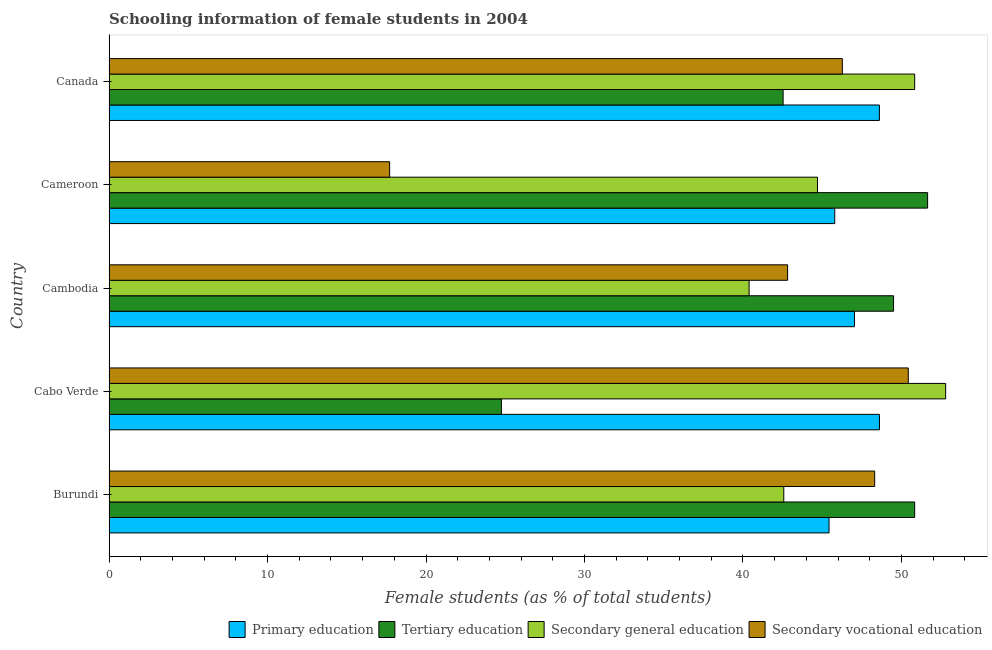How many different coloured bars are there?
Your answer should be compact. 4. How many groups of bars are there?
Provide a short and direct response. 5. Are the number of bars on each tick of the Y-axis equal?
Your answer should be compact. Yes. How many bars are there on the 5th tick from the top?
Your response must be concise. 4. What is the label of the 2nd group of bars from the top?
Make the answer very short. Cameroon. What is the percentage of female students in primary education in Burundi?
Keep it short and to the point. 45.43. Across all countries, what is the maximum percentage of female students in tertiary education?
Your answer should be very brief. 51.65. Across all countries, what is the minimum percentage of female students in secondary vocational education?
Make the answer very short. 17.7. In which country was the percentage of female students in secondary vocational education maximum?
Provide a succinct answer. Cabo Verde. In which country was the percentage of female students in tertiary education minimum?
Offer a terse response. Cabo Verde. What is the total percentage of female students in secondary vocational education in the graph?
Keep it short and to the point. 205.53. What is the difference between the percentage of female students in secondary vocational education in Burundi and that in Cambodia?
Keep it short and to the point. 5.5. What is the difference between the percentage of female students in tertiary education in Burundi and the percentage of female students in secondary education in Canada?
Keep it short and to the point. 0. What is the average percentage of female students in secondary education per country?
Offer a very short reply. 46.26. What is the difference between the percentage of female students in secondary vocational education and percentage of female students in tertiary education in Burundi?
Offer a terse response. -2.52. What is the ratio of the percentage of female students in secondary education in Burundi to that in Canada?
Offer a terse response. 0.84. Is the percentage of female students in tertiary education in Cabo Verde less than that in Cameroon?
Your answer should be very brief. Yes. Is the difference between the percentage of female students in tertiary education in Burundi and Cameroon greater than the difference between the percentage of female students in secondary vocational education in Burundi and Cameroon?
Your answer should be compact. No. What is the difference between the highest and the second highest percentage of female students in secondary education?
Your answer should be very brief. 1.96. What is the difference between the highest and the lowest percentage of female students in secondary vocational education?
Offer a terse response. 32.73. In how many countries, is the percentage of female students in primary education greater than the average percentage of female students in primary education taken over all countries?
Your response must be concise. 2. What does the 3rd bar from the top in Cameroon represents?
Offer a terse response. Tertiary education. What does the 1st bar from the bottom in Canada represents?
Ensure brevity in your answer.  Primary education. How many countries are there in the graph?
Keep it short and to the point. 5. What is the difference between two consecutive major ticks on the X-axis?
Provide a succinct answer. 10. Does the graph contain any zero values?
Offer a very short reply. No. Does the graph contain grids?
Ensure brevity in your answer.  No. Where does the legend appear in the graph?
Your response must be concise. Bottom right. How are the legend labels stacked?
Give a very brief answer. Horizontal. What is the title of the graph?
Your answer should be very brief. Schooling information of female students in 2004. Does "Permanent crop land" appear as one of the legend labels in the graph?
Provide a succinct answer. No. What is the label or title of the X-axis?
Your answer should be very brief. Female students (as % of total students). What is the Female students (as % of total students) in Primary education in Burundi?
Keep it short and to the point. 45.43. What is the Female students (as % of total students) of Tertiary education in Burundi?
Make the answer very short. 50.83. What is the Female students (as % of total students) of Secondary general education in Burundi?
Ensure brevity in your answer.  42.57. What is the Female students (as % of total students) of Secondary vocational education in Burundi?
Offer a very short reply. 48.31. What is the Female students (as % of total students) in Primary education in Cabo Verde?
Keep it short and to the point. 48.61. What is the Female students (as % of total students) in Tertiary education in Cabo Verde?
Offer a very short reply. 24.76. What is the Female students (as % of total students) in Secondary general education in Cabo Verde?
Give a very brief answer. 52.79. What is the Female students (as % of total students) of Secondary vocational education in Cabo Verde?
Provide a succinct answer. 50.43. What is the Female students (as % of total students) in Primary education in Cambodia?
Your answer should be very brief. 47.03. What is the Female students (as % of total students) in Tertiary education in Cambodia?
Your answer should be very brief. 49.5. What is the Female students (as % of total students) in Secondary general education in Cambodia?
Your response must be concise. 40.39. What is the Female students (as % of total students) of Secondary vocational education in Cambodia?
Provide a succinct answer. 42.81. What is the Female students (as % of total students) of Primary education in Cameroon?
Give a very brief answer. 45.79. What is the Female students (as % of total students) in Tertiary education in Cameroon?
Make the answer very short. 51.65. What is the Female students (as % of total students) in Secondary general education in Cameroon?
Your answer should be very brief. 44.7. What is the Female students (as % of total students) of Secondary vocational education in Cameroon?
Offer a very short reply. 17.7. What is the Female students (as % of total students) of Primary education in Canada?
Provide a short and direct response. 48.61. What is the Female students (as % of total students) in Tertiary education in Canada?
Give a very brief answer. 42.53. What is the Female students (as % of total students) in Secondary general education in Canada?
Offer a very short reply. 50.83. What is the Female students (as % of total students) in Secondary vocational education in Canada?
Provide a short and direct response. 46.27. Across all countries, what is the maximum Female students (as % of total students) in Primary education?
Provide a succinct answer. 48.61. Across all countries, what is the maximum Female students (as % of total students) of Tertiary education?
Offer a very short reply. 51.65. Across all countries, what is the maximum Female students (as % of total students) in Secondary general education?
Keep it short and to the point. 52.79. Across all countries, what is the maximum Female students (as % of total students) in Secondary vocational education?
Give a very brief answer. 50.43. Across all countries, what is the minimum Female students (as % of total students) in Primary education?
Provide a succinct answer. 45.43. Across all countries, what is the minimum Female students (as % of total students) in Tertiary education?
Give a very brief answer. 24.76. Across all countries, what is the minimum Female students (as % of total students) of Secondary general education?
Make the answer very short. 40.39. Across all countries, what is the minimum Female students (as % of total students) in Secondary vocational education?
Offer a very short reply. 17.7. What is the total Female students (as % of total students) in Primary education in the graph?
Offer a terse response. 235.47. What is the total Female students (as % of total students) of Tertiary education in the graph?
Make the answer very short. 219.27. What is the total Female students (as % of total students) of Secondary general education in the graph?
Keep it short and to the point. 231.28. What is the total Female students (as % of total students) in Secondary vocational education in the graph?
Your answer should be compact. 205.53. What is the difference between the Female students (as % of total students) in Primary education in Burundi and that in Cabo Verde?
Your response must be concise. -3.18. What is the difference between the Female students (as % of total students) of Tertiary education in Burundi and that in Cabo Verde?
Your response must be concise. 26.08. What is the difference between the Female students (as % of total students) of Secondary general education in Burundi and that in Cabo Verde?
Your answer should be compact. -10.21. What is the difference between the Female students (as % of total students) in Secondary vocational education in Burundi and that in Cabo Verde?
Your response must be concise. -2.12. What is the difference between the Female students (as % of total students) in Primary education in Burundi and that in Cambodia?
Ensure brevity in your answer.  -1.6. What is the difference between the Female students (as % of total students) of Tertiary education in Burundi and that in Cambodia?
Ensure brevity in your answer.  1.33. What is the difference between the Female students (as % of total students) in Secondary general education in Burundi and that in Cambodia?
Your response must be concise. 2.19. What is the difference between the Female students (as % of total students) of Secondary vocational education in Burundi and that in Cambodia?
Keep it short and to the point. 5.49. What is the difference between the Female students (as % of total students) in Primary education in Burundi and that in Cameroon?
Your answer should be very brief. -0.36. What is the difference between the Female students (as % of total students) in Tertiary education in Burundi and that in Cameroon?
Provide a short and direct response. -0.82. What is the difference between the Female students (as % of total students) of Secondary general education in Burundi and that in Cameroon?
Ensure brevity in your answer.  -2.13. What is the difference between the Female students (as % of total students) of Secondary vocational education in Burundi and that in Cameroon?
Make the answer very short. 30.6. What is the difference between the Female students (as % of total students) of Primary education in Burundi and that in Canada?
Provide a short and direct response. -3.18. What is the difference between the Female students (as % of total students) in Tertiary education in Burundi and that in Canada?
Provide a short and direct response. 8.3. What is the difference between the Female students (as % of total students) in Secondary general education in Burundi and that in Canada?
Keep it short and to the point. -8.26. What is the difference between the Female students (as % of total students) of Secondary vocational education in Burundi and that in Canada?
Make the answer very short. 2.04. What is the difference between the Female students (as % of total students) of Primary education in Cabo Verde and that in Cambodia?
Your answer should be compact. 1.58. What is the difference between the Female students (as % of total students) in Tertiary education in Cabo Verde and that in Cambodia?
Your answer should be very brief. -24.74. What is the difference between the Female students (as % of total students) in Secondary general education in Cabo Verde and that in Cambodia?
Your answer should be very brief. 12.4. What is the difference between the Female students (as % of total students) in Secondary vocational education in Cabo Verde and that in Cambodia?
Give a very brief answer. 7.62. What is the difference between the Female students (as % of total students) in Primary education in Cabo Verde and that in Cameroon?
Give a very brief answer. 2.82. What is the difference between the Female students (as % of total students) in Tertiary education in Cabo Verde and that in Cameroon?
Give a very brief answer. -26.89. What is the difference between the Female students (as % of total students) of Secondary general education in Cabo Verde and that in Cameroon?
Offer a very short reply. 8.09. What is the difference between the Female students (as % of total students) of Secondary vocational education in Cabo Verde and that in Cameroon?
Make the answer very short. 32.73. What is the difference between the Female students (as % of total students) of Primary education in Cabo Verde and that in Canada?
Your response must be concise. 0. What is the difference between the Female students (as % of total students) of Tertiary education in Cabo Verde and that in Canada?
Offer a very short reply. -17.78. What is the difference between the Female students (as % of total students) in Secondary general education in Cabo Verde and that in Canada?
Ensure brevity in your answer.  1.96. What is the difference between the Female students (as % of total students) in Secondary vocational education in Cabo Verde and that in Canada?
Keep it short and to the point. 4.16. What is the difference between the Female students (as % of total students) of Primary education in Cambodia and that in Cameroon?
Your answer should be compact. 1.24. What is the difference between the Female students (as % of total students) in Tertiary education in Cambodia and that in Cameroon?
Ensure brevity in your answer.  -2.15. What is the difference between the Female students (as % of total students) of Secondary general education in Cambodia and that in Cameroon?
Provide a short and direct response. -4.31. What is the difference between the Female students (as % of total students) of Secondary vocational education in Cambodia and that in Cameroon?
Give a very brief answer. 25.11. What is the difference between the Female students (as % of total students) of Primary education in Cambodia and that in Canada?
Your response must be concise. -1.57. What is the difference between the Female students (as % of total students) in Tertiary education in Cambodia and that in Canada?
Keep it short and to the point. 6.97. What is the difference between the Female students (as % of total students) of Secondary general education in Cambodia and that in Canada?
Ensure brevity in your answer.  -10.45. What is the difference between the Female students (as % of total students) in Secondary vocational education in Cambodia and that in Canada?
Provide a short and direct response. -3.45. What is the difference between the Female students (as % of total students) of Primary education in Cameroon and that in Canada?
Offer a terse response. -2.82. What is the difference between the Female students (as % of total students) in Tertiary education in Cameroon and that in Canada?
Your response must be concise. 9.12. What is the difference between the Female students (as % of total students) of Secondary general education in Cameroon and that in Canada?
Your answer should be compact. -6.13. What is the difference between the Female students (as % of total students) in Secondary vocational education in Cameroon and that in Canada?
Offer a terse response. -28.56. What is the difference between the Female students (as % of total students) of Primary education in Burundi and the Female students (as % of total students) of Tertiary education in Cabo Verde?
Offer a very short reply. 20.67. What is the difference between the Female students (as % of total students) of Primary education in Burundi and the Female students (as % of total students) of Secondary general education in Cabo Verde?
Your answer should be compact. -7.36. What is the difference between the Female students (as % of total students) in Primary education in Burundi and the Female students (as % of total students) in Secondary vocational education in Cabo Verde?
Give a very brief answer. -5. What is the difference between the Female students (as % of total students) in Tertiary education in Burundi and the Female students (as % of total students) in Secondary general education in Cabo Verde?
Give a very brief answer. -1.96. What is the difference between the Female students (as % of total students) in Tertiary education in Burundi and the Female students (as % of total students) in Secondary vocational education in Cabo Verde?
Your answer should be compact. 0.4. What is the difference between the Female students (as % of total students) of Secondary general education in Burundi and the Female students (as % of total students) of Secondary vocational education in Cabo Verde?
Make the answer very short. -7.86. What is the difference between the Female students (as % of total students) of Primary education in Burundi and the Female students (as % of total students) of Tertiary education in Cambodia?
Give a very brief answer. -4.07. What is the difference between the Female students (as % of total students) of Primary education in Burundi and the Female students (as % of total students) of Secondary general education in Cambodia?
Offer a terse response. 5.04. What is the difference between the Female students (as % of total students) of Primary education in Burundi and the Female students (as % of total students) of Secondary vocational education in Cambodia?
Offer a terse response. 2.61. What is the difference between the Female students (as % of total students) of Tertiary education in Burundi and the Female students (as % of total students) of Secondary general education in Cambodia?
Make the answer very short. 10.45. What is the difference between the Female students (as % of total students) in Tertiary education in Burundi and the Female students (as % of total students) in Secondary vocational education in Cambodia?
Your answer should be very brief. 8.02. What is the difference between the Female students (as % of total students) in Secondary general education in Burundi and the Female students (as % of total students) in Secondary vocational education in Cambodia?
Your response must be concise. -0.24. What is the difference between the Female students (as % of total students) in Primary education in Burundi and the Female students (as % of total students) in Tertiary education in Cameroon?
Provide a succinct answer. -6.22. What is the difference between the Female students (as % of total students) of Primary education in Burundi and the Female students (as % of total students) of Secondary general education in Cameroon?
Ensure brevity in your answer.  0.73. What is the difference between the Female students (as % of total students) of Primary education in Burundi and the Female students (as % of total students) of Secondary vocational education in Cameroon?
Provide a short and direct response. 27.73. What is the difference between the Female students (as % of total students) of Tertiary education in Burundi and the Female students (as % of total students) of Secondary general education in Cameroon?
Your answer should be compact. 6.13. What is the difference between the Female students (as % of total students) in Tertiary education in Burundi and the Female students (as % of total students) in Secondary vocational education in Cameroon?
Ensure brevity in your answer.  33.13. What is the difference between the Female students (as % of total students) of Secondary general education in Burundi and the Female students (as % of total students) of Secondary vocational education in Cameroon?
Keep it short and to the point. 24.87. What is the difference between the Female students (as % of total students) in Primary education in Burundi and the Female students (as % of total students) in Tertiary education in Canada?
Give a very brief answer. 2.9. What is the difference between the Female students (as % of total students) of Primary education in Burundi and the Female students (as % of total students) of Secondary general education in Canada?
Offer a very short reply. -5.4. What is the difference between the Female students (as % of total students) of Primary education in Burundi and the Female students (as % of total students) of Secondary vocational education in Canada?
Make the answer very short. -0.84. What is the difference between the Female students (as % of total students) in Tertiary education in Burundi and the Female students (as % of total students) in Secondary general education in Canada?
Offer a terse response. 0. What is the difference between the Female students (as % of total students) of Tertiary education in Burundi and the Female students (as % of total students) of Secondary vocational education in Canada?
Ensure brevity in your answer.  4.56. What is the difference between the Female students (as % of total students) of Secondary general education in Burundi and the Female students (as % of total students) of Secondary vocational education in Canada?
Your response must be concise. -3.69. What is the difference between the Female students (as % of total students) in Primary education in Cabo Verde and the Female students (as % of total students) in Tertiary education in Cambodia?
Keep it short and to the point. -0.89. What is the difference between the Female students (as % of total students) of Primary education in Cabo Verde and the Female students (as % of total students) of Secondary general education in Cambodia?
Your response must be concise. 8.22. What is the difference between the Female students (as % of total students) of Primary education in Cabo Verde and the Female students (as % of total students) of Secondary vocational education in Cambodia?
Give a very brief answer. 5.79. What is the difference between the Female students (as % of total students) of Tertiary education in Cabo Verde and the Female students (as % of total students) of Secondary general education in Cambodia?
Offer a very short reply. -15.63. What is the difference between the Female students (as % of total students) in Tertiary education in Cabo Verde and the Female students (as % of total students) in Secondary vocational education in Cambodia?
Your answer should be compact. -18.06. What is the difference between the Female students (as % of total students) of Secondary general education in Cabo Verde and the Female students (as % of total students) of Secondary vocational education in Cambodia?
Provide a short and direct response. 9.97. What is the difference between the Female students (as % of total students) in Primary education in Cabo Verde and the Female students (as % of total students) in Tertiary education in Cameroon?
Offer a terse response. -3.04. What is the difference between the Female students (as % of total students) of Primary education in Cabo Verde and the Female students (as % of total students) of Secondary general education in Cameroon?
Keep it short and to the point. 3.91. What is the difference between the Female students (as % of total students) of Primary education in Cabo Verde and the Female students (as % of total students) of Secondary vocational education in Cameroon?
Make the answer very short. 30.91. What is the difference between the Female students (as % of total students) in Tertiary education in Cabo Verde and the Female students (as % of total students) in Secondary general education in Cameroon?
Your response must be concise. -19.94. What is the difference between the Female students (as % of total students) in Tertiary education in Cabo Verde and the Female students (as % of total students) in Secondary vocational education in Cameroon?
Offer a terse response. 7.05. What is the difference between the Female students (as % of total students) of Secondary general education in Cabo Verde and the Female students (as % of total students) of Secondary vocational education in Cameroon?
Provide a short and direct response. 35.08. What is the difference between the Female students (as % of total students) of Primary education in Cabo Verde and the Female students (as % of total students) of Tertiary education in Canada?
Provide a short and direct response. 6.08. What is the difference between the Female students (as % of total students) in Primary education in Cabo Verde and the Female students (as % of total students) in Secondary general education in Canada?
Provide a short and direct response. -2.22. What is the difference between the Female students (as % of total students) of Primary education in Cabo Verde and the Female students (as % of total students) of Secondary vocational education in Canada?
Keep it short and to the point. 2.34. What is the difference between the Female students (as % of total students) of Tertiary education in Cabo Verde and the Female students (as % of total students) of Secondary general education in Canada?
Your answer should be very brief. -26.08. What is the difference between the Female students (as % of total students) in Tertiary education in Cabo Verde and the Female students (as % of total students) in Secondary vocational education in Canada?
Offer a very short reply. -21.51. What is the difference between the Female students (as % of total students) of Secondary general education in Cabo Verde and the Female students (as % of total students) of Secondary vocational education in Canada?
Your response must be concise. 6.52. What is the difference between the Female students (as % of total students) in Primary education in Cambodia and the Female students (as % of total students) in Tertiary education in Cameroon?
Offer a terse response. -4.62. What is the difference between the Female students (as % of total students) of Primary education in Cambodia and the Female students (as % of total students) of Secondary general education in Cameroon?
Give a very brief answer. 2.33. What is the difference between the Female students (as % of total students) in Primary education in Cambodia and the Female students (as % of total students) in Secondary vocational education in Cameroon?
Provide a succinct answer. 29.33. What is the difference between the Female students (as % of total students) in Tertiary education in Cambodia and the Female students (as % of total students) in Secondary general education in Cameroon?
Provide a short and direct response. 4.8. What is the difference between the Female students (as % of total students) of Tertiary education in Cambodia and the Female students (as % of total students) of Secondary vocational education in Cameroon?
Offer a very short reply. 31.8. What is the difference between the Female students (as % of total students) in Secondary general education in Cambodia and the Female students (as % of total students) in Secondary vocational education in Cameroon?
Give a very brief answer. 22.68. What is the difference between the Female students (as % of total students) of Primary education in Cambodia and the Female students (as % of total students) of Tertiary education in Canada?
Your response must be concise. 4.5. What is the difference between the Female students (as % of total students) of Primary education in Cambodia and the Female students (as % of total students) of Secondary general education in Canada?
Offer a very short reply. -3.8. What is the difference between the Female students (as % of total students) of Primary education in Cambodia and the Female students (as % of total students) of Secondary vocational education in Canada?
Keep it short and to the point. 0.76. What is the difference between the Female students (as % of total students) in Tertiary education in Cambodia and the Female students (as % of total students) in Secondary general education in Canada?
Provide a succinct answer. -1.33. What is the difference between the Female students (as % of total students) of Tertiary education in Cambodia and the Female students (as % of total students) of Secondary vocational education in Canada?
Keep it short and to the point. 3.23. What is the difference between the Female students (as % of total students) in Secondary general education in Cambodia and the Female students (as % of total students) in Secondary vocational education in Canada?
Offer a very short reply. -5.88. What is the difference between the Female students (as % of total students) in Primary education in Cameroon and the Female students (as % of total students) in Tertiary education in Canada?
Make the answer very short. 3.26. What is the difference between the Female students (as % of total students) in Primary education in Cameroon and the Female students (as % of total students) in Secondary general education in Canada?
Keep it short and to the point. -5.04. What is the difference between the Female students (as % of total students) in Primary education in Cameroon and the Female students (as % of total students) in Secondary vocational education in Canada?
Your answer should be compact. -0.48. What is the difference between the Female students (as % of total students) in Tertiary education in Cameroon and the Female students (as % of total students) in Secondary general education in Canada?
Your response must be concise. 0.82. What is the difference between the Female students (as % of total students) in Tertiary education in Cameroon and the Female students (as % of total students) in Secondary vocational education in Canada?
Give a very brief answer. 5.38. What is the difference between the Female students (as % of total students) of Secondary general education in Cameroon and the Female students (as % of total students) of Secondary vocational education in Canada?
Provide a short and direct response. -1.57. What is the average Female students (as % of total students) in Primary education per country?
Your response must be concise. 47.09. What is the average Female students (as % of total students) of Tertiary education per country?
Your answer should be compact. 43.85. What is the average Female students (as % of total students) of Secondary general education per country?
Ensure brevity in your answer.  46.26. What is the average Female students (as % of total students) in Secondary vocational education per country?
Your answer should be compact. 41.11. What is the difference between the Female students (as % of total students) in Primary education and Female students (as % of total students) in Tertiary education in Burundi?
Make the answer very short. -5.4. What is the difference between the Female students (as % of total students) in Primary education and Female students (as % of total students) in Secondary general education in Burundi?
Offer a very short reply. 2.85. What is the difference between the Female students (as % of total students) of Primary education and Female students (as % of total students) of Secondary vocational education in Burundi?
Give a very brief answer. -2.88. What is the difference between the Female students (as % of total students) of Tertiary education and Female students (as % of total students) of Secondary general education in Burundi?
Keep it short and to the point. 8.26. What is the difference between the Female students (as % of total students) of Tertiary education and Female students (as % of total students) of Secondary vocational education in Burundi?
Your response must be concise. 2.52. What is the difference between the Female students (as % of total students) in Secondary general education and Female students (as % of total students) in Secondary vocational education in Burundi?
Make the answer very short. -5.73. What is the difference between the Female students (as % of total students) of Primary education and Female students (as % of total students) of Tertiary education in Cabo Verde?
Make the answer very short. 23.85. What is the difference between the Female students (as % of total students) in Primary education and Female students (as % of total students) in Secondary general education in Cabo Verde?
Your answer should be very brief. -4.18. What is the difference between the Female students (as % of total students) of Primary education and Female students (as % of total students) of Secondary vocational education in Cabo Verde?
Provide a succinct answer. -1.82. What is the difference between the Female students (as % of total students) in Tertiary education and Female students (as % of total students) in Secondary general education in Cabo Verde?
Give a very brief answer. -28.03. What is the difference between the Female students (as % of total students) in Tertiary education and Female students (as % of total students) in Secondary vocational education in Cabo Verde?
Offer a terse response. -25.67. What is the difference between the Female students (as % of total students) in Secondary general education and Female students (as % of total students) in Secondary vocational education in Cabo Verde?
Your answer should be very brief. 2.36. What is the difference between the Female students (as % of total students) of Primary education and Female students (as % of total students) of Tertiary education in Cambodia?
Give a very brief answer. -2.47. What is the difference between the Female students (as % of total students) of Primary education and Female students (as % of total students) of Secondary general education in Cambodia?
Offer a very short reply. 6.65. What is the difference between the Female students (as % of total students) of Primary education and Female students (as % of total students) of Secondary vocational education in Cambodia?
Provide a short and direct response. 4.22. What is the difference between the Female students (as % of total students) of Tertiary education and Female students (as % of total students) of Secondary general education in Cambodia?
Provide a short and direct response. 9.11. What is the difference between the Female students (as % of total students) of Tertiary education and Female students (as % of total students) of Secondary vocational education in Cambodia?
Your answer should be compact. 6.69. What is the difference between the Female students (as % of total students) in Secondary general education and Female students (as % of total students) in Secondary vocational education in Cambodia?
Offer a terse response. -2.43. What is the difference between the Female students (as % of total students) in Primary education and Female students (as % of total students) in Tertiary education in Cameroon?
Offer a very short reply. -5.86. What is the difference between the Female students (as % of total students) in Primary education and Female students (as % of total students) in Secondary general education in Cameroon?
Ensure brevity in your answer.  1.09. What is the difference between the Female students (as % of total students) of Primary education and Female students (as % of total students) of Secondary vocational education in Cameroon?
Offer a terse response. 28.08. What is the difference between the Female students (as % of total students) in Tertiary education and Female students (as % of total students) in Secondary general education in Cameroon?
Ensure brevity in your answer.  6.95. What is the difference between the Female students (as % of total students) of Tertiary education and Female students (as % of total students) of Secondary vocational education in Cameroon?
Your response must be concise. 33.95. What is the difference between the Female students (as % of total students) of Secondary general education and Female students (as % of total students) of Secondary vocational education in Cameroon?
Offer a very short reply. 27. What is the difference between the Female students (as % of total students) in Primary education and Female students (as % of total students) in Tertiary education in Canada?
Your answer should be very brief. 6.08. What is the difference between the Female students (as % of total students) of Primary education and Female students (as % of total students) of Secondary general education in Canada?
Your answer should be very brief. -2.23. What is the difference between the Female students (as % of total students) in Primary education and Female students (as % of total students) in Secondary vocational education in Canada?
Provide a short and direct response. 2.34. What is the difference between the Female students (as % of total students) of Tertiary education and Female students (as % of total students) of Secondary general education in Canada?
Your answer should be compact. -8.3. What is the difference between the Female students (as % of total students) in Tertiary education and Female students (as % of total students) in Secondary vocational education in Canada?
Your answer should be very brief. -3.74. What is the difference between the Female students (as % of total students) in Secondary general education and Female students (as % of total students) in Secondary vocational education in Canada?
Your answer should be very brief. 4.56. What is the ratio of the Female students (as % of total students) of Primary education in Burundi to that in Cabo Verde?
Make the answer very short. 0.93. What is the ratio of the Female students (as % of total students) in Tertiary education in Burundi to that in Cabo Verde?
Your answer should be compact. 2.05. What is the ratio of the Female students (as % of total students) in Secondary general education in Burundi to that in Cabo Verde?
Your response must be concise. 0.81. What is the ratio of the Female students (as % of total students) of Secondary vocational education in Burundi to that in Cabo Verde?
Your response must be concise. 0.96. What is the ratio of the Female students (as % of total students) of Primary education in Burundi to that in Cambodia?
Your response must be concise. 0.97. What is the ratio of the Female students (as % of total students) in Tertiary education in Burundi to that in Cambodia?
Ensure brevity in your answer.  1.03. What is the ratio of the Female students (as % of total students) of Secondary general education in Burundi to that in Cambodia?
Provide a succinct answer. 1.05. What is the ratio of the Female students (as % of total students) in Secondary vocational education in Burundi to that in Cambodia?
Provide a short and direct response. 1.13. What is the ratio of the Female students (as % of total students) of Primary education in Burundi to that in Cameroon?
Provide a short and direct response. 0.99. What is the ratio of the Female students (as % of total students) of Tertiary education in Burundi to that in Cameroon?
Offer a very short reply. 0.98. What is the ratio of the Female students (as % of total students) of Secondary general education in Burundi to that in Cameroon?
Make the answer very short. 0.95. What is the ratio of the Female students (as % of total students) of Secondary vocational education in Burundi to that in Cameroon?
Give a very brief answer. 2.73. What is the ratio of the Female students (as % of total students) in Primary education in Burundi to that in Canada?
Give a very brief answer. 0.93. What is the ratio of the Female students (as % of total students) in Tertiary education in Burundi to that in Canada?
Keep it short and to the point. 1.2. What is the ratio of the Female students (as % of total students) of Secondary general education in Burundi to that in Canada?
Offer a terse response. 0.84. What is the ratio of the Female students (as % of total students) of Secondary vocational education in Burundi to that in Canada?
Ensure brevity in your answer.  1.04. What is the ratio of the Female students (as % of total students) of Primary education in Cabo Verde to that in Cambodia?
Make the answer very short. 1.03. What is the ratio of the Female students (as % of total students) of Tertiary education in Cabo Verde to that in Cambodia?
Give a very brief answer. 0.5. What is the ratio of the Female students (as % of total students) in Secondary general education in Cabo Verde to that in Cambodia?
Your answer should be compact. 1.31. What is the ratio of the Female students (as % of total students) of Secondary vocational education in Cabo Verde to that in Cambodia?
Your answer should be compact. 1.18. What is the ratio of the Female students (as % of total students) of Primary education in Cabo Verde to that in Cameroon?
Keep it short and to the point. 1.06. What is the ratio of the Female students (as % of total students) in Tertiary education in Cabo Verde to that in Cameroon?
Provide a short and direct response. 0.48. What is the ratio of the Female students (as % of total students) of Secondary general education in Cabo Verde to that in Cameroon?
Offer a very short reply. 1.18. What is the ratio of the Female students (as % of total students) in Secondary vocational education in Cabo Verde to that in Cameroon?
Your answer should be very brief. 2.85. What is the ratio of the Female students (as % of total students) of Tertiary education in Cabo Verde to that in Canada?
Provide a succinct answer. 0.58. What is the ratio of the Female students (as % of total students) of Secondary general education in Cabo Verde to that in Canada?
Your response must be concise. 1.04. What is the ratio of the Female students (as % of total students) of Secondary vocational education in Cabo Verde to that in Canada?
Provide a short and direct response. 1.09. What is the ratio of the Female students (as % of total students) of Primary education in Cambodia to that in Cameroon?
Ensure brevity in your answer.  1.03. What is the ratio of the Female students (as % of total students) of Tertiary education in Cambodia to that in Cameroon?
Your answer should be very brief. 0.96. What is the ratio of the Female students (as % of total students) in Secondary general education in Cambodia to that in Cameroon?
Give a very brief answer. 0.9. What is the ratio of the Female students (as % of total students) in Secondary vocational education in Cambodia to that in Cameroon?
Offer a very short reply. 2.42. What is the ratio of the Female students (as % of total students) in Primary education in Cambodia to that in Canada?
Your answer should be compact. 0.97. What is the ratio of the Female students (as % of total students) of Tertiary education in Cambodia to that in Canada?
Keep it short and to the point. 1.16. What is the ratio of the Female students (as % of total students) of Secondary general education in Cambodia to that in Canada?
Offer a very short reply. 0.79. What is the ratio of the Female students (as % of total students) in Secondary vocational education in Cambodia to that in Canada?
Provide a succinct answer. 0.93. What is the ratio of the Female students (as % of total students) in Primary education in Cameroon to that in Canada?
Provide a short and direct response. 0.94. What is the ratio of the Female students (as % of total students) of Tertiary education in Cameroon to that in Canada?
Keep it short and to the point. 1.21. What is the ratio of the Female students (as % of total students) in Secondary general education in Cameroon to that in Canada?
Offer a terse response. 0.88. What is the ratio of the Female students (as % of total students) of Secondary vocational education in Cameroon to that in Canada?
Your response must be concise. 0.38. What is the difference between the highest and the second highest Female students (as % of total students) of Primary education?
Offer a terse response. 0. What is the difference between the highest and the second highest Female students (as % of total students) in Tertiary education?
Offer a very short reply. 0.82. What is the difference between the highest and the second highest Female students (as % of total students) of Secondary general education?
Ensure brevity in your answer.  1.96. What is the difference between the highest and the second highest Female students (as % of total students) of Secondary vocational education?
Offer a very short reply. 2.12. What is the difference between the highest and the lowest Female students (as % of total students) of Primary education?
Your response must be concise. 3.18. What is the difference between the highest and the lowest Female students (as % of total students) of Tertiary education?
Offer a terse response. 26.89. What is the difference between the highest and the lowest Female students (as % of total students) of Secondary general education?
Offer a terse response. 12.4. What is the difference between the highest and the lowest Female students (as % of total students) in Secondary vocational education?
Provide a succinct answer. 32.73. 